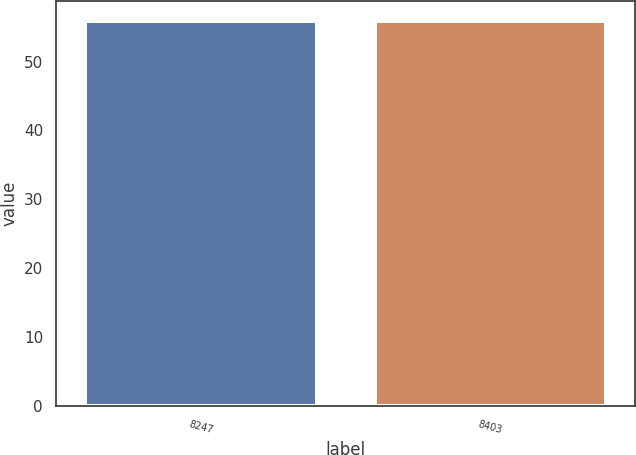Convert chart to OTSL. <chart><loc_0><loc_0><loc_500><loc_500><bar_chart><fcel>8247<fcel>8403<nl><fcel>55.88<fcel>55.98<nl></chart> 